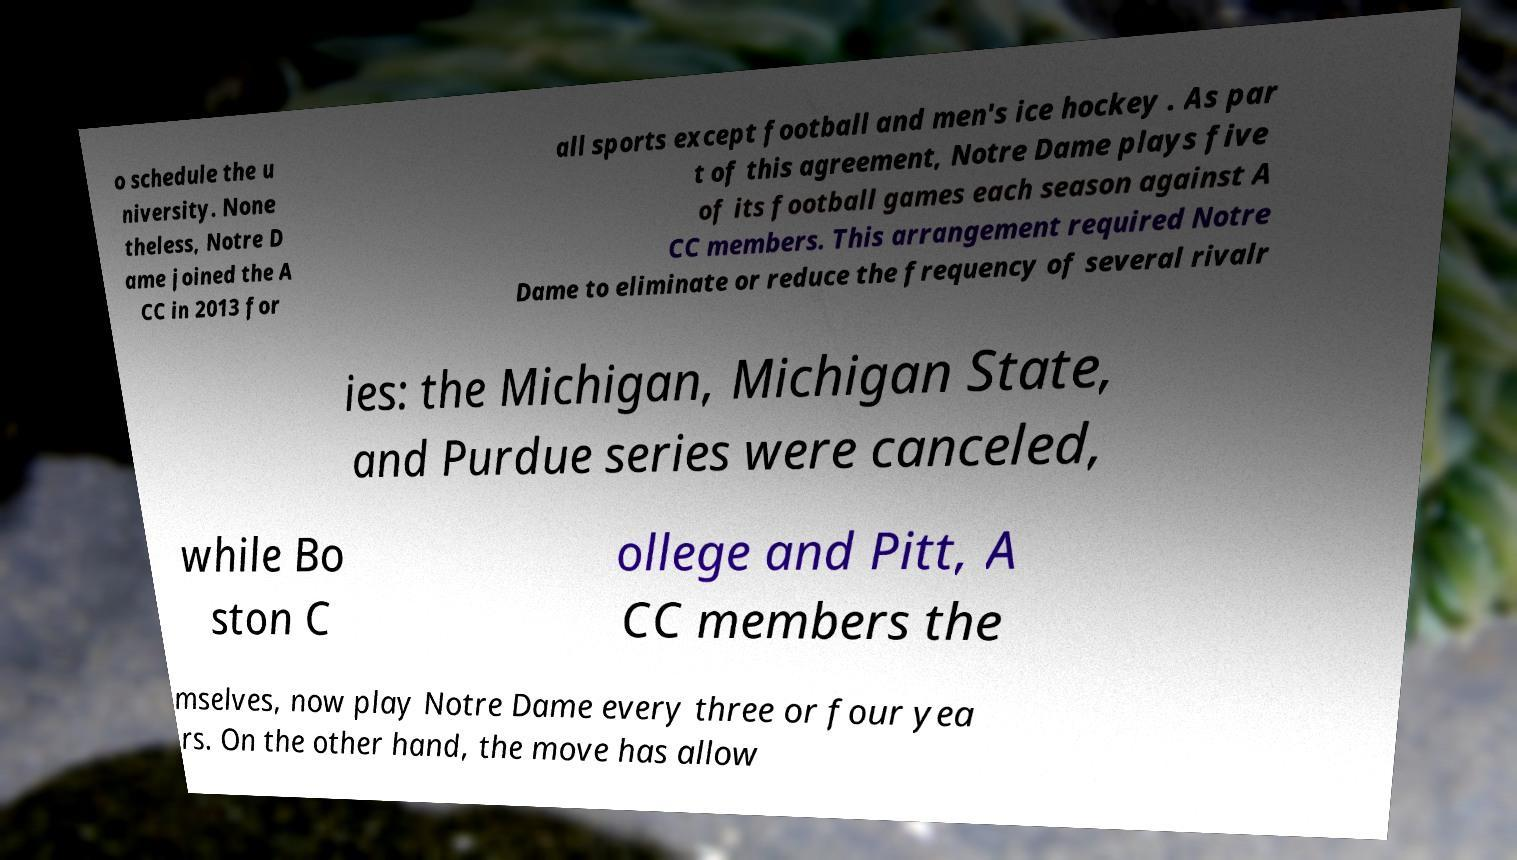For documentation purposes, I need the text within this image transcribed. Could you provide that? o schedule the u niversity. None theless, Notre D ame joined the A CC in 2013 for all sports except football and men's ice hockey . As par t of this agreement, Notre Dame plays five of its football games each season against A CC members. This arrangement required Notre Dame to eliminate or reduce the frequency of several rivalr ies: the Michigan, Michigan State, and Purdue series were canceled, while Bo ston C ollege and Pitt, A CC members the mselves, now play Notre Dame every three or four yea rs. On the other hand, the move has allow 